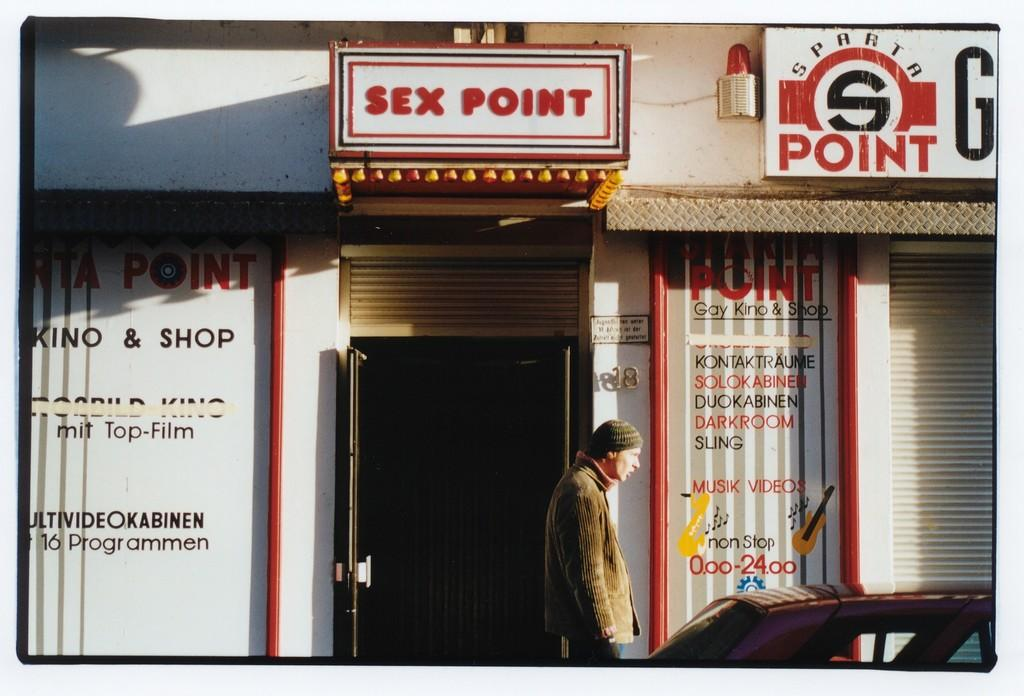Who is present in the image? There is a man in the image. What is the man standing in front of? The man is standing in front of a store. What else can be seen on the right side of the image? There is a car on the right side of the image. Where is the harbor located in the image? There is no harbor present in the image. What type of bead is being used to decorate the lamp in the image? There is no lamp present in the image, so it is not possible to determine what type of bead might be used for decoration. 